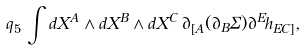<formula> <loc_0><loc_0><loc_500><loc_500>q _ { 5 } \, \int d X ^ { A } \wedge d X ^ { B } \wedge d X ^ { C } \, \partial _ { [ A } ( \partial _ { B } \Sigma ) \partial ^ { E } h _ { E C ] } ,</formula> 